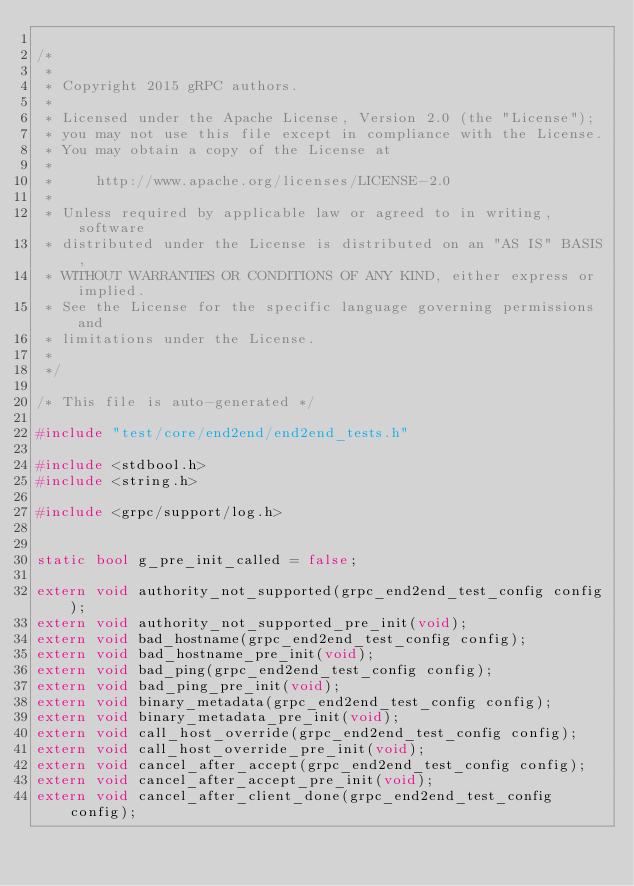Convert code to text. <code><loc_0><loc_0><loc_500><loc_500><_C++_>
/*
 *
 * Copyright 2015 gRPC authors.
 *
 * Licensed under the Apache License, Version 2.0 (the "License");
 * you may not use this file except in compliance with the License.
 * You may obtain a copy of the License at
 *
 *     http://www.apache.org/licenses/LICENSE-2.0
 *
 * Unless required by applicable law or agreed to in writing, software
 * distributed under the License is distributed on an "AS IS" BASIS,
 * WITHOUT WARRANTIES OR CONDITIONS OF ANY KIND, either express or implied.
 * See the License for the specific language governing permissions and
 * limitations under the License.
 *
 */

/* This file is auto-generated */

#include "test/core/end2end/end2end_tests.h"

#include <stdbool.h>
#include <string.h>

#include <grpc/support/log.h>


static bool g_pre_init_called = false;

extern void authority_not_supported(grpc_end2end_test_config config);
extern void authority_not_supported_pre_init(void);
extern void bad_hostname(grpc_end2end_test_config config);
extern void bad_hostname_pre_init(void);
extern void bad_ping(grpc_end2end_test_config config);
extern void bad_ping_pre_init(void);
extern void binary_metadata(grpc_end2end_test_config config);
extern void binary_metadata_pre_init(void);
extern void call_host_override(grpc_end2end_test_config config);
extern void call_host_override_pre_init(void);
extern void cancel_after_accept(grpc_end2end_test_config config);
extern void cancel_after_accept_pre_init(void);
extern void cancel_after_client_done(grpc_end2end_test_config config);</code> 